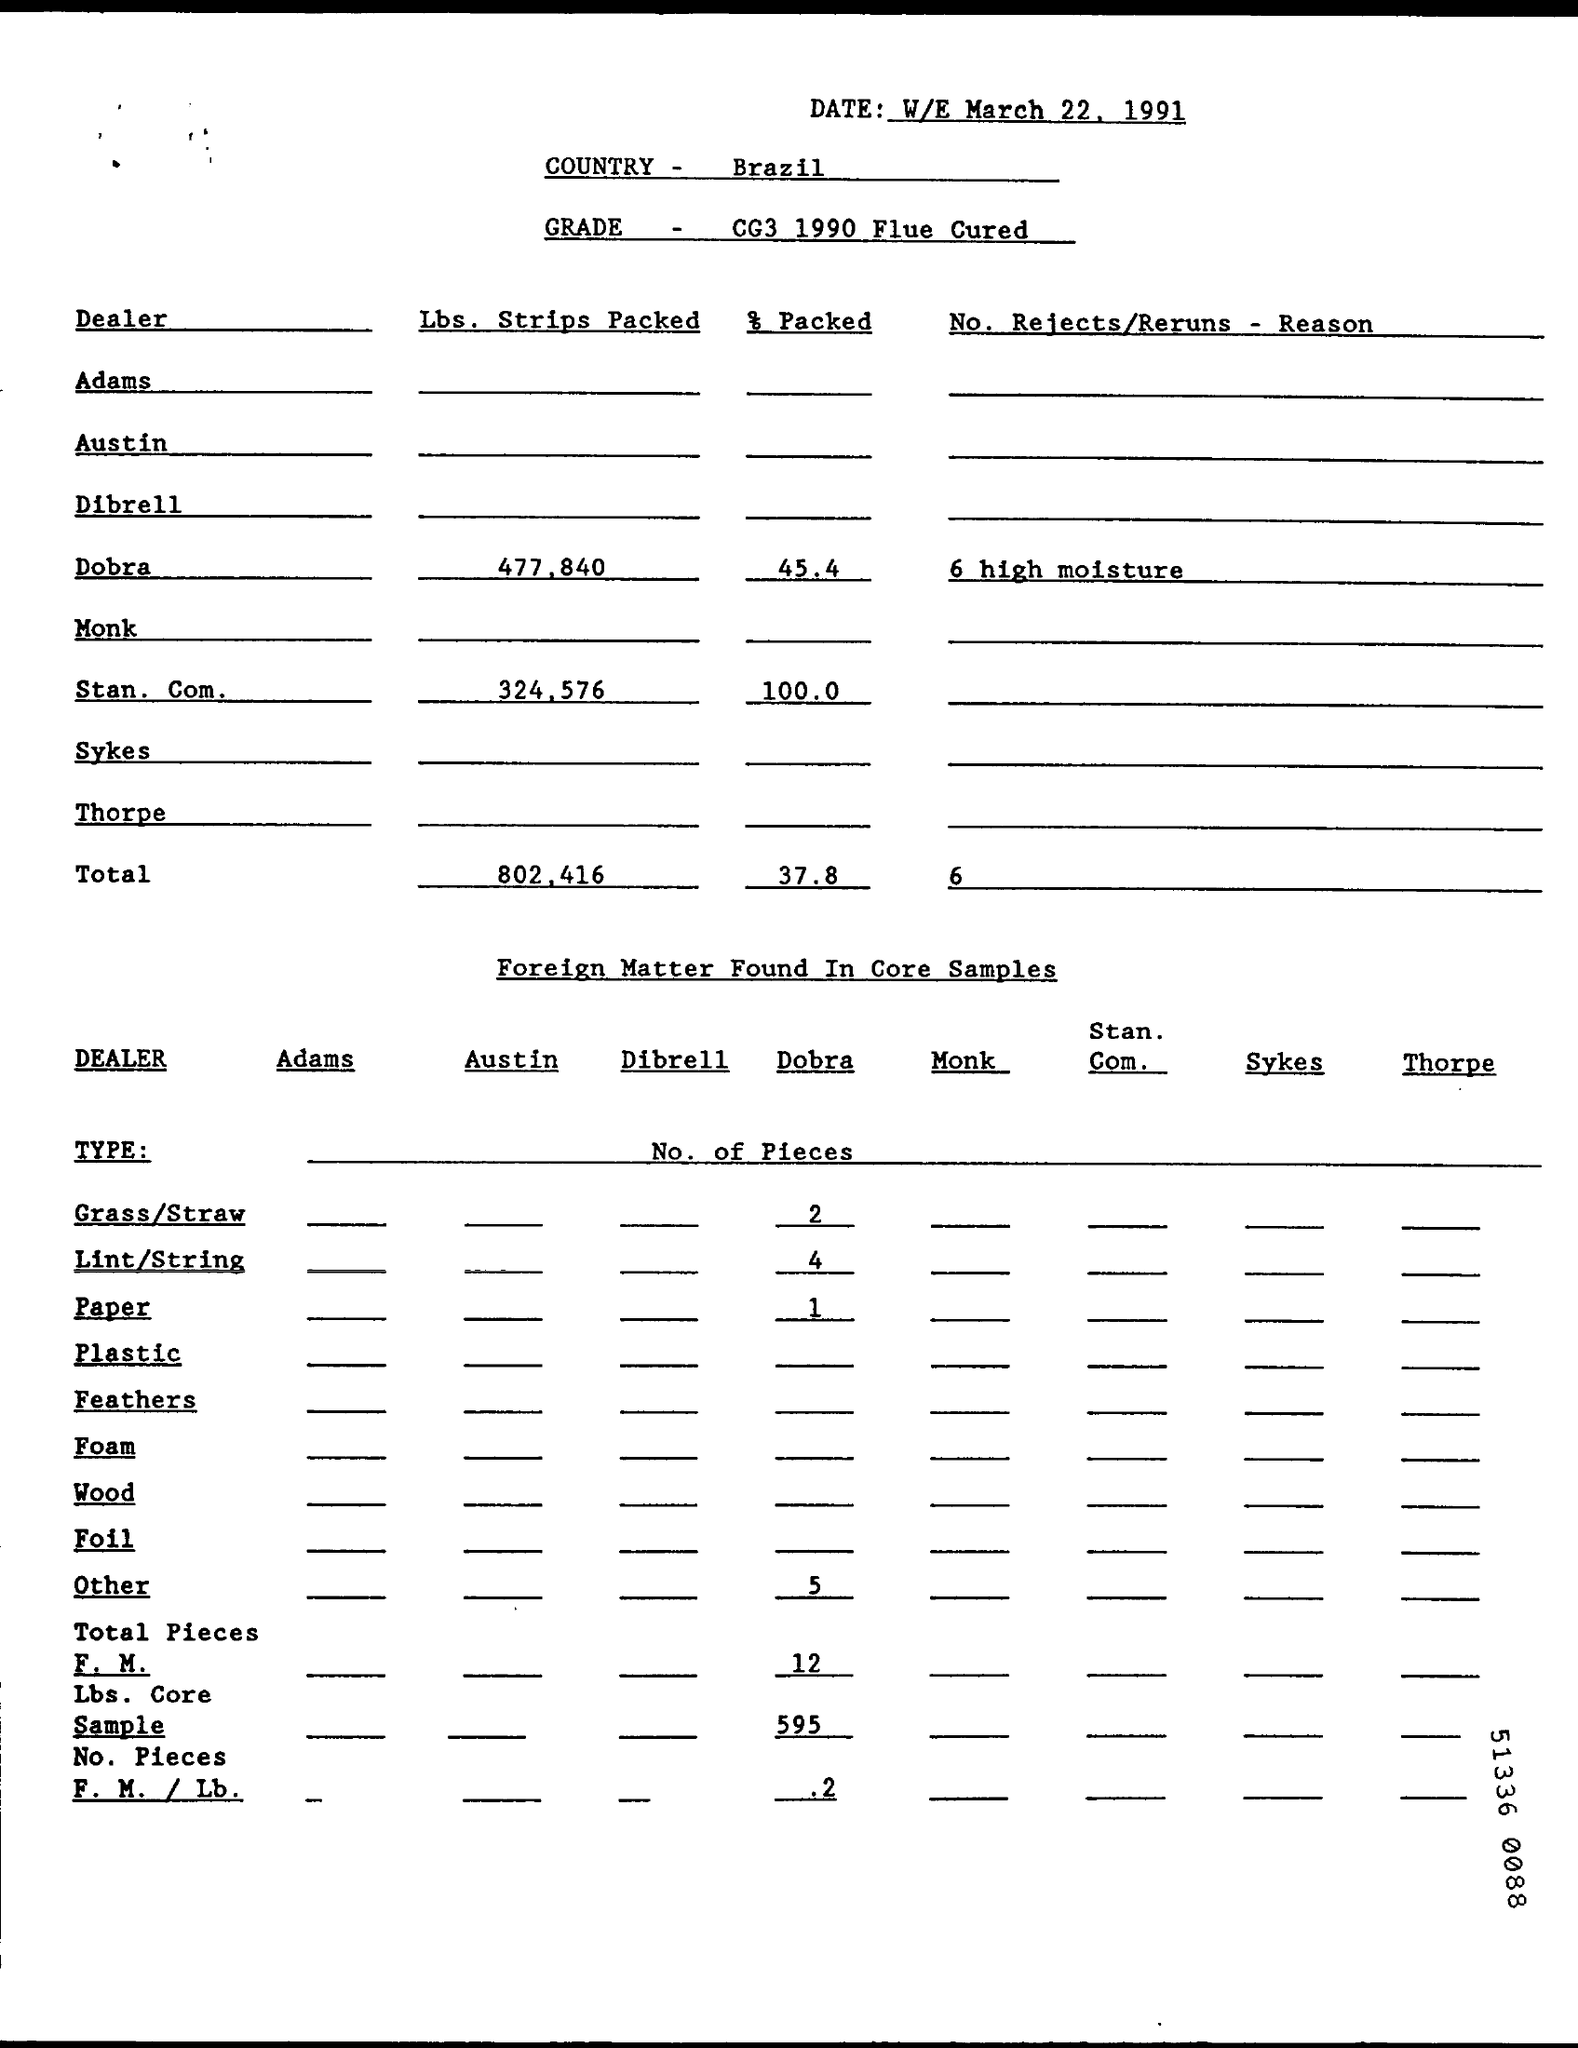What is the date on the document?
Offer a very short reply. W/E March 22, 1991. What is the Grade?
Provide a succinct answer. CG3 1990 Flue Cured. What is the Lbs. Strips Packed for Dobra?
Make the answer very short. 477.840. What is the Lbs. Strips Packed for Stan. Com.?
Your answer should be compact. 324.576. What is the total lbs. strips packed?
Your answer should be very brief. 802.416. What is the % Packed for Dobra?
Ensure brevity in your answer.  45.4. What is the % Packed for Stan. Com.?
Offer a terse response. 100.0. What is the total % packed?
Offer a terse response. 37.8. 